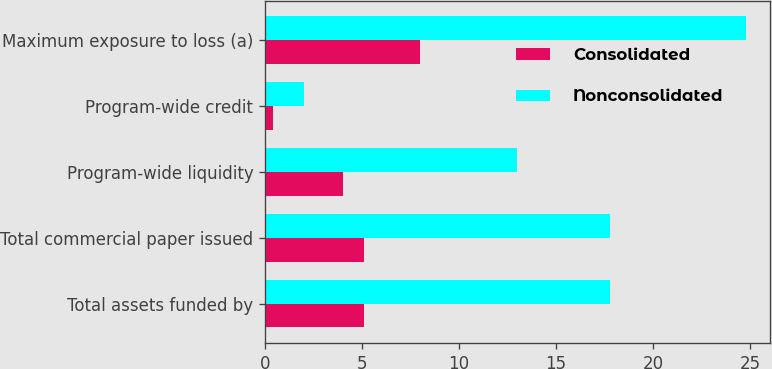Convert chart. <chart><loc_0><loc_0><loc_500><loc_500><stacked_bar_chart><ecel><fcel>Total assets funded by<fcel>Total commercial paper issued<fcel>Program-wide liquidity<fcel>Program-wide credit<fcel>Maximum exposure to loss (a)<nl><fcel>Consolidated<fcel>5.1<fcel>5.1<fcel>4<fcel>0.4<fcel>8<nl><fcel>Nonconsolidated<fcel>17.8<fcel>17.8<fcel>13<fcel>2<fcel>24.8<nl></chart> 